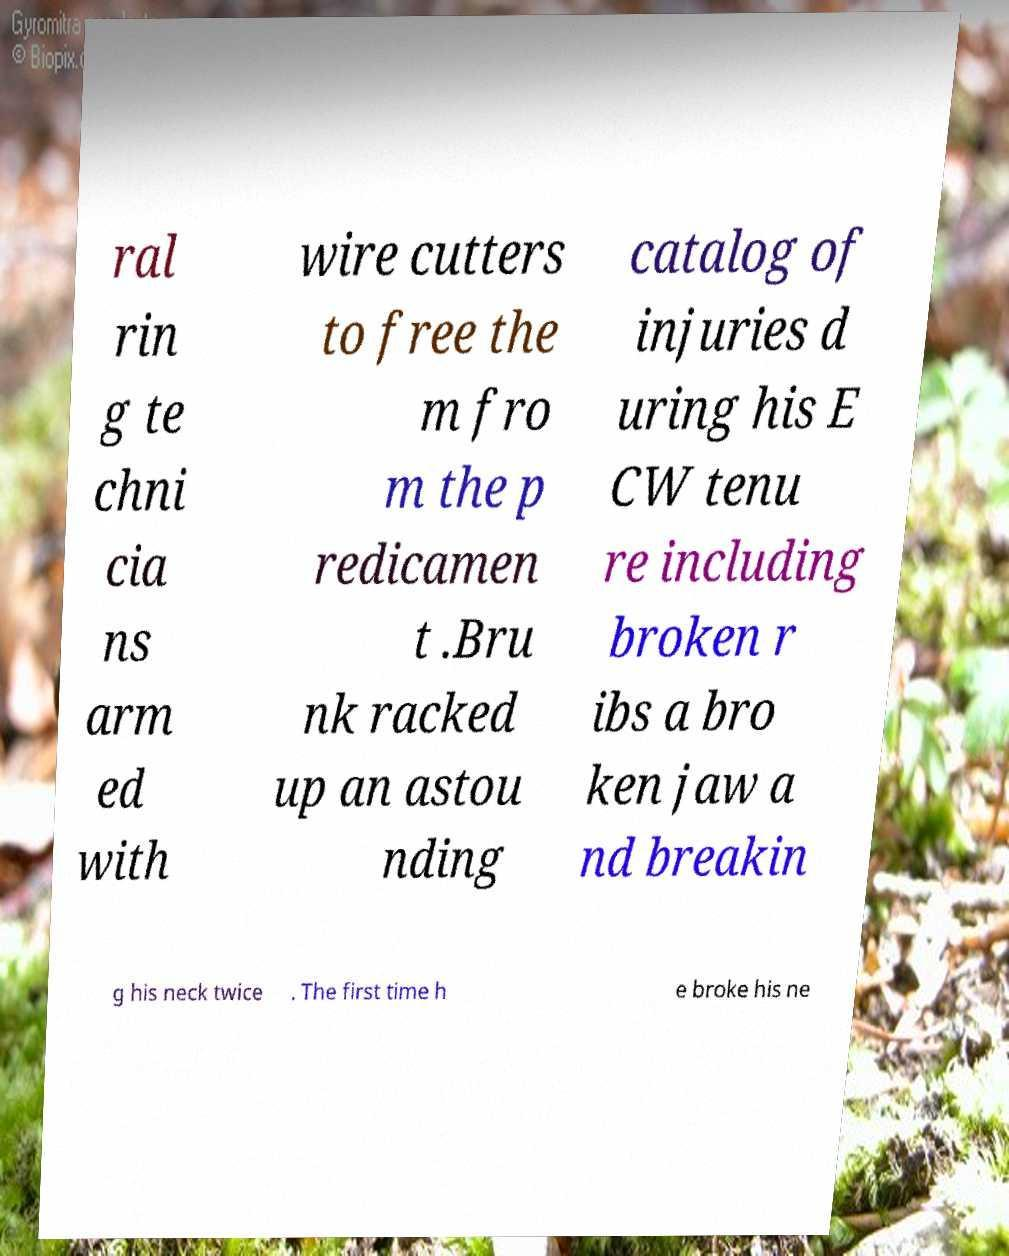I need the written content from this picture converted into text. Can you do that? ral rin g te chni cia ns arm ed with wire cutters to free the m fro m the p redicamen t .Bru nk racked up an astou nding catalog of injuries d uring his E CW tenu re including broken r ibs a bro ken jaw a nd breakin g his neck twice . The first time h e broke his ne 